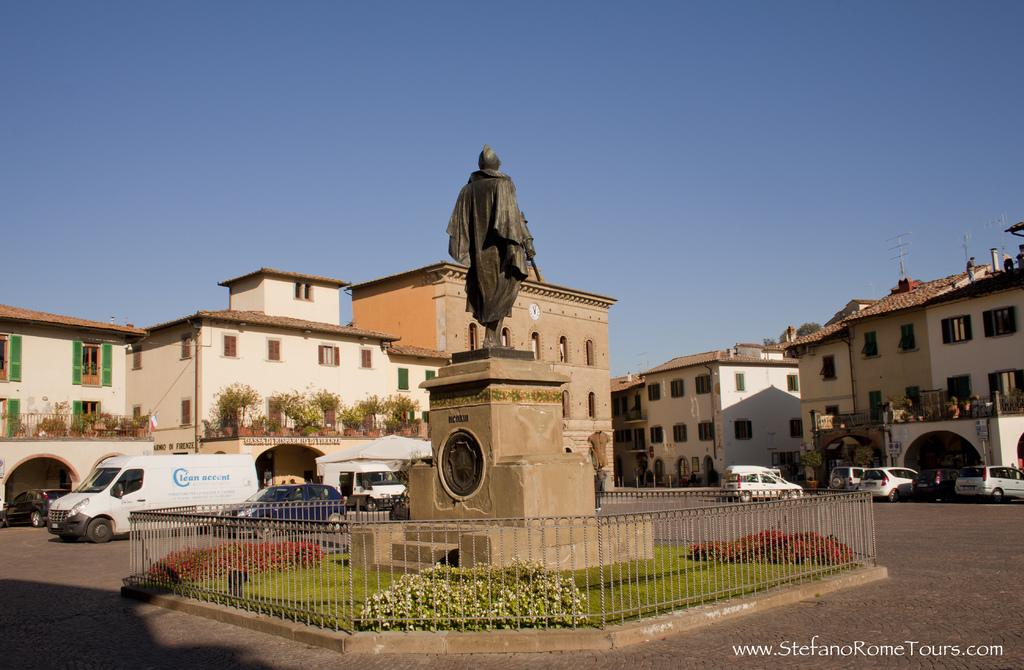What type of structures can be seen in the image? There are buildings in the image. What other elements are present in the image besides buildings? There are plants, vehicles on the road, a statue, and railing in the image. What can be seen in the background of the image? The sky is visible in the background of the image. How many eggs are being used to power the statue in the image? There are no eggs or references to powering the statue in the image. The statue is a standalone feature, and its construction or power source is not mentioned or depicted. 